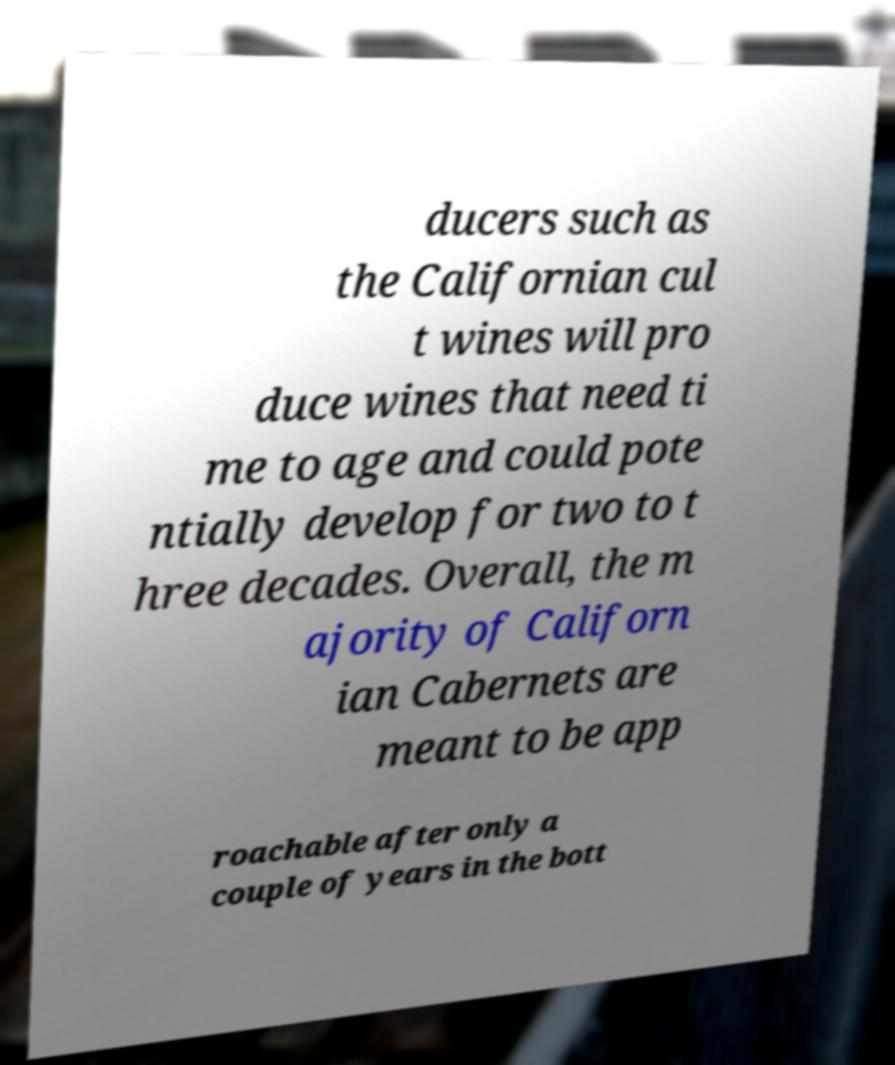Please identify and transcribe the text found in this image. ducers such as the Californian cul t wines will pro duce wines that need ti me to age and could pote ntially develop for two to t hree decades. Overall, the m ajority of Californ ian Cabernets are meant to be app roachable after only a couple of years in the bott 